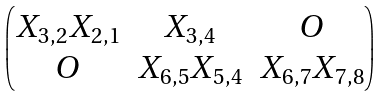Convert formula to latex. <formula><loc_0><loc_0><loc_500><loc_500>\begin{pmatrix} X _ { 3 , 2 } X _ { 2 , 1 } & X _ { 3 , 4 } & O \\ O & X _ { 6 , 5 } X _ { 5 , 4 } & X _ { 6 , 7 } X _ { 7 , 8 } \end{pmatrix}</formula> 